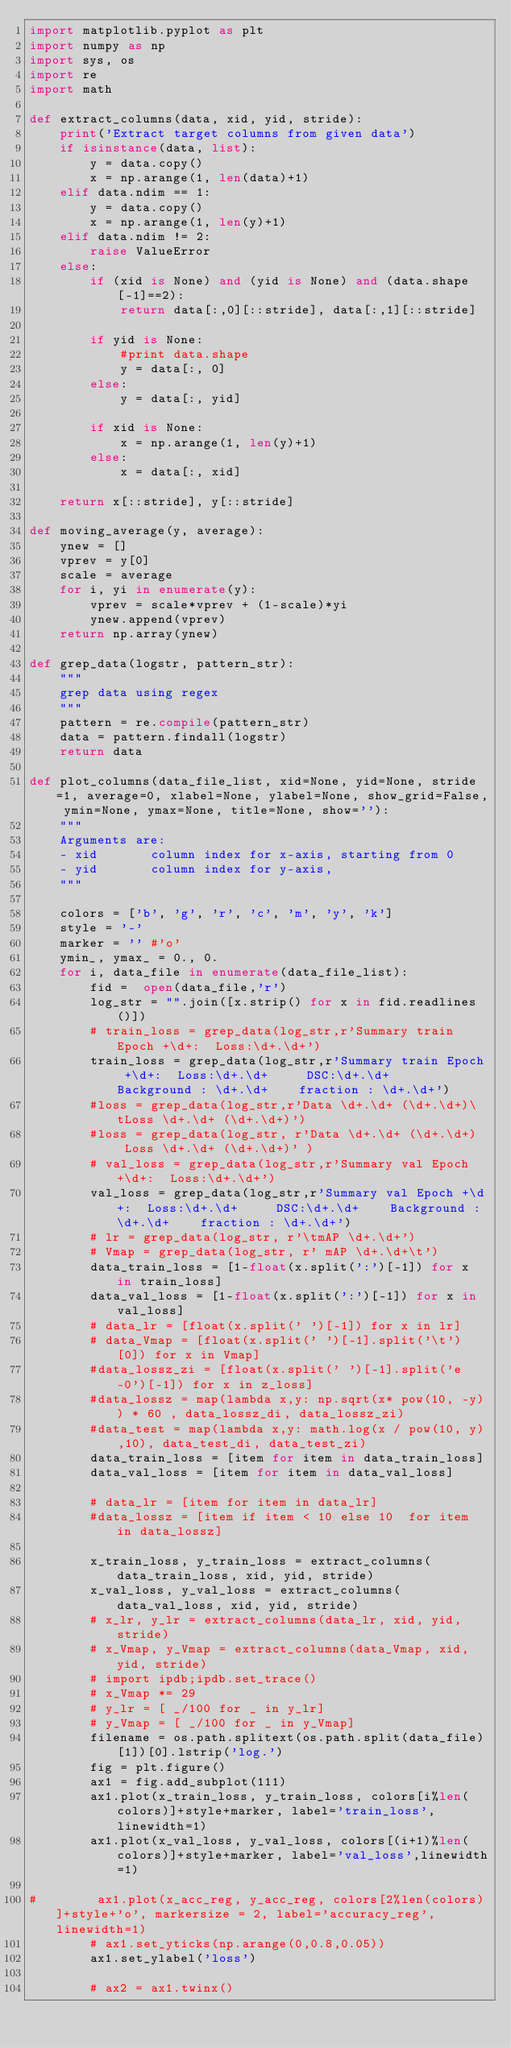Convert code to text. <code><loc_0><loc_0><loc_500><loc_500><_Python_>import matplotlib.pyplot as plt
import numpy as np
import sys, os
import re
import math

def extract_columns(data, xid, yid, stride):
    print('Extract target columns from given data')
    if isinstance(data, list):
        y = data.copy()
        x = np.arange(1, len(data)+1)
    elif data.ndim == 1:
        y = data.copy()
        x = np.arange(1, len(y)+1)
    elif data.ndim != 2:
        raise ValueError
    else:
        if (xid is None) and (yid is None) and (data.shape[-1]==2):
            return data[:,0][::stride], data[:,1][::stride]

        if yid is None:
            #print data.shape
            y = data[:, 0]
        else:
            y = data[:, yid]

        if xid is None:
            x = np.arange(1, len(y)+1)
        else:
            x = data[:, xid]

    return x[::stride], y[::stride]

def moving_average(y, average):
    ynew = []
    vprev = y[0]
    scale = average
    for i, yi in enumerate(y):
        vprev = scale*vprev + (1-scale)*yi
        ynew.append(vprev)
    return np.array(ynew)

def grep_data(logstr, pattern_str):
    """
    grep data using regex
    """
    pattern = re.compile(pattern_str)
    data = pattern.findall(logstr)
    return data

def plot_columns(data_file_list, xid=None, yid=None, stride=1, average=0, xlabel=None, ylabel=None, show_grid=False, ymin=None, ymax=None, title=None, show=''):
    """
    Arguments are:
    - xid       column index for x-axis, starting from 0
    - yid       column index for y-axis, 
    """
    
    colors = ['b', 'g', 'r', 'c', 'm', 'y', 'k']
    style = '-'
    marker = '' #'o'
    ymin_, ymax_ = 0., 0.
    for i, data_file in enumerate(data_file_list):
        fid =  open(data_file,'r') 
        log_str = "".join([x.strip() for x in fid.readlines()])
        # train_loss = grep_data(log_str,r'Summary train Epoch +\d+:  Loss:\d+.\d+') 
        train_loss = grep_data(log_str,r'Summary train Epoch +\d+:  Loss:\d+.\d+ 	 DSC:\d+.\d+  	Background : \d+.\d+	fraction : \d+.\d+') 
        #loss = grep_data(log_str,r'Data \d+.\d+ (\d+.\d+)\tLoss \d+.\d+ (\d+.\d+)') 
        #loss = grep_data(log_str, r'Data \d+.\d+ (\d+.\d+)  Loss \d+.\d+ (\d+.\d+)' )
        # val_loss = grep_data(log_str,r'Summary val Epoch +\d+:  Loss:\d+.\d+') 
        val_loss = grep_data(log_str,r'Summary val Epoch +\d+:  Loss:\d+.\d+ 	 DSC:\d+.\d+  	Background : \d+.\d+	fraction : \d+.\d+') 
        # lr = grep_data(log_str, r'\tmAP \d+.\d+')
        # Vmap = grep_data(log_str, r' mAP \d+.\d+\t')
        data_train_loss = [1-float(x.split(':')[-1]) for x in train_loss]
        data_val_loss = [1-float(x.split(':')[-1]) for x in val_loss]
        # data_lr = [float(x.split(' ')[-1]) for x in lr]
        # data_Vmap = [float(x.split(' ')[-1].split('\t')[0]) for x in Vmap]
        #data_lossz_zi = [float(x.split(' ')[-1].split('e-0')[-1]) for x in z_loss]
        #data_lossz = map(lambda x,y: np.sqrt(x* pow(10, -y)) * 60 , data_lossz_di, data_lossz_zi)
        #data_test = map(lambda x,y: math.log(x / pow(10, y),10), data_test_di, data_test_zi)
        data_train_loss = [item for item in data_train_loss]
        data_val_loss = [item for item in data_val_loss]

        # data_lr = [item for item in data_lr]
        #data_lossz = [item if item < 10 else 10  for item in data_lossz]
        
        x_train_loss, y_train_loss = extract_columns(data_train_loss, xid, yid, stride)
        x_val_loss, y_val_loss = extract_columns(data_val_loss, xid, yid, stride)
        # x_lr, y_lr = extract_columns(data_lr, xid, yid, stride)
        # x_Vmap, y_Vmap = extract_columns(data_Vmap, xid, yid, stride)
        # import ipdb;ipdb.set_trace() 
        # x_Vmap *= 29
        # y_lr = [ _/100 for _ in y_lr]
        # y_Vmap = [ _/100 for _ in y_Vmap]
        filename = os.path.splitext(os.path.split(data_file)[1])[0].lstrip('log.')
        fig = plt.figure()
        ax1 = fig.add_subplot(111)
        ax1.plot(x_train_loss, y_train_loss, colors[i%len(colors)]+style+marker, label='train_loss',linewidth=1)
        ax1.plot(x_val_loss, y_val_loss, colors[(i+1)%len(colors)]+style+marker, label='val_loss',linewidth=1)

#        ax1.plot(x_acc_reg, y_acc_reg, colors[2%len(colors)]+style+'o', markersize = 2, label='accuracy_reg',linewidth=1)
        # ax1.set_yticks(np.arange(0,0.8,0.05)) 
        ax1.set_ylabel('loss')
        
        # ax2 = ax1.twinx()</code> 